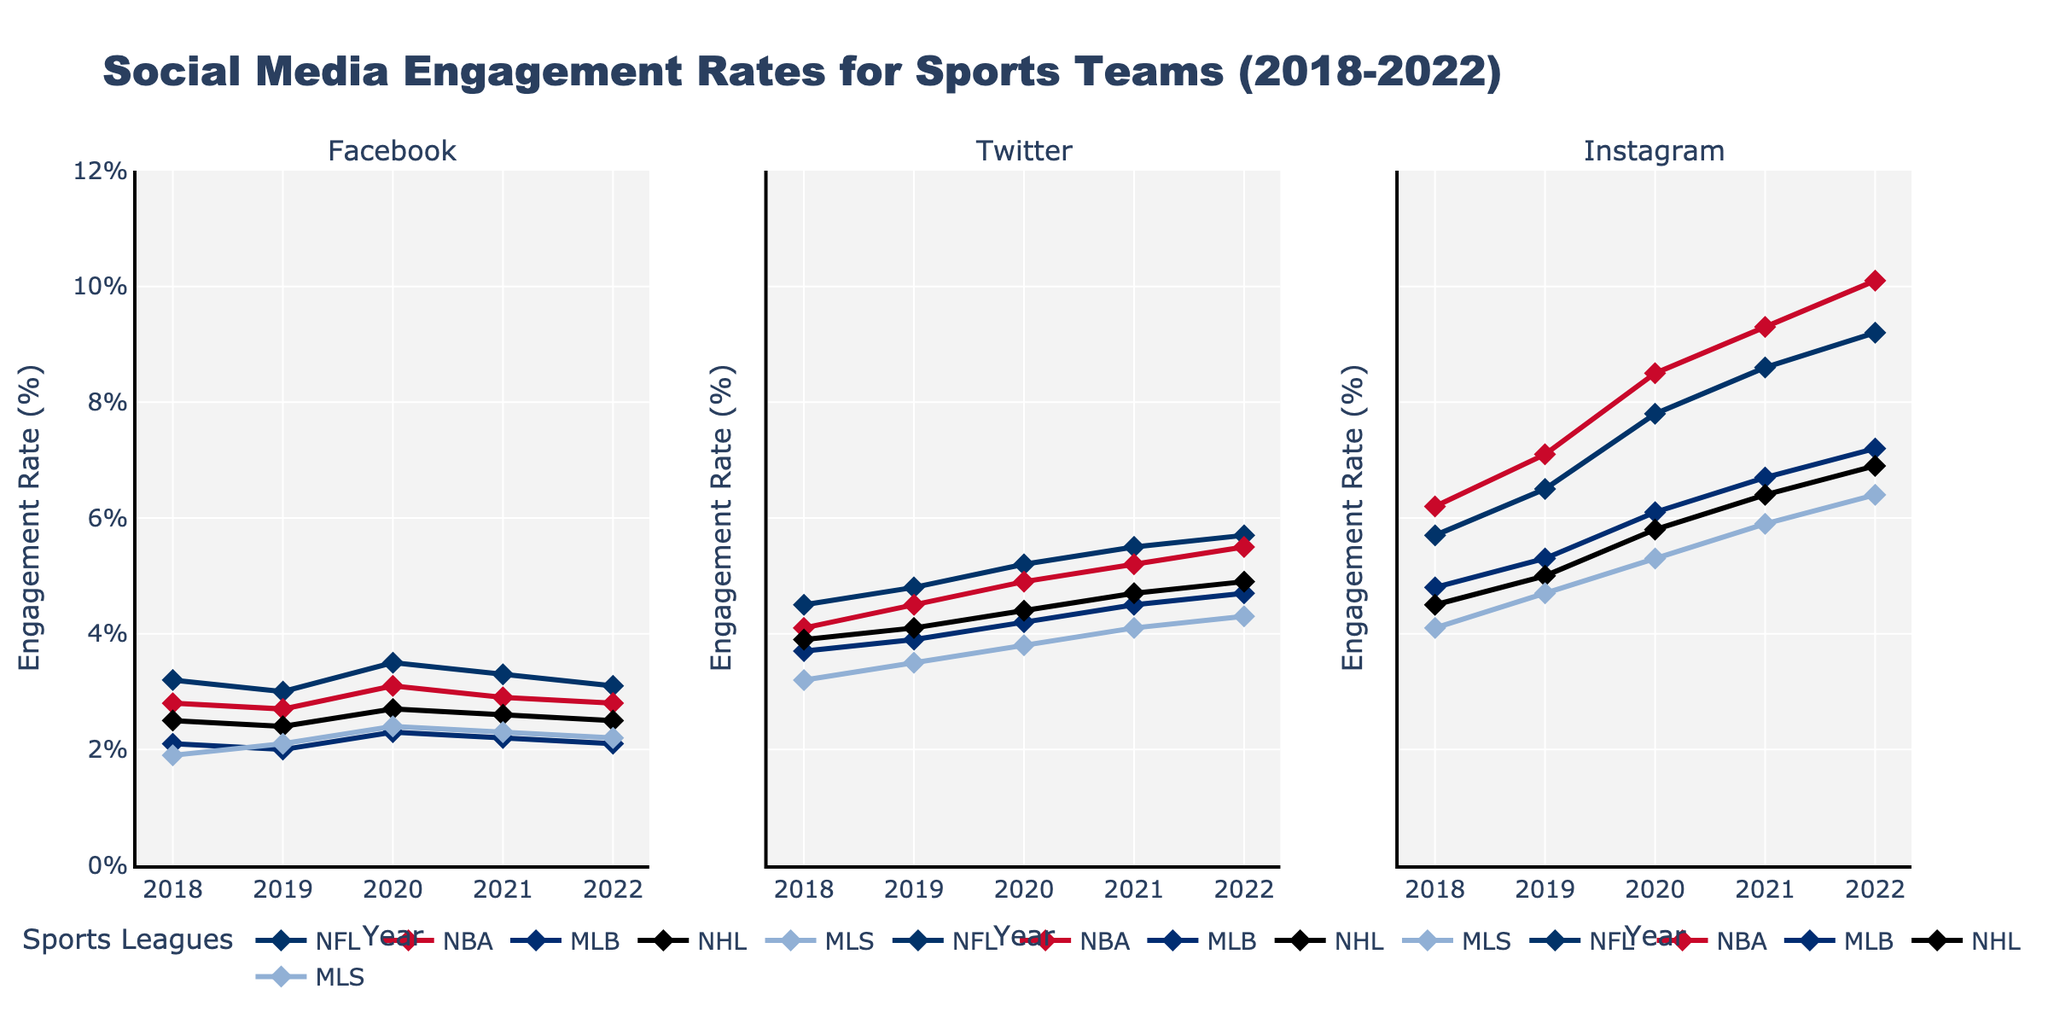Which platform had the highest engagement rate for the NBA in 2022? To find this, look at the Instagram, Facebook, and Twitter plots for 2022 under the NBA marker. The highest engagement rate for the NBA in 2022 is visible on the Instagram plot.
Answer: Instagram Which sport had the lowest engagement rate on Facebook in 2021? To identify the sport with the lowest engagement rate on Facebook in 2021, look at the Facebook plot under the 2021 marker and compare the engagement rates for all the sports. The lowest engagement rate is visible for the NFL.
Answer: NFL How did the engagement rates change for MLS on Instagram from 2018 to 2022? To determine this, observe the plot for Instagram and track the points related to MLS from 2018 to 2022. Calculate the difference between the values. The rates increased from 4.1% in 2018 to 6.4% in 2022.
Answer: Increased by 2.3% Which year did the NFL have the highest engagement rate on Twitter, and what was the value? Check the Twitter sub-plot for the NFL line and compare the values for each year. The highest rate for the NFL on Twitter was in 2022 at 5.7%.
Answer: 2022, 5.7% Does Instagram consistently show the highest engagement rates across all sports compared to Facebook and Twitter from 2018 to 2022? To evaluate consistency, compare the engagement rates across all three platforms each year for a given sport. You'll notice that Instagram consistently shows higher engagement rates than Facebook and Twitter for all sports throughout 2018 to 2022.
Answer: Yes What is the average engagement rate for the NBA on Twitter across all shown years? Calculate the average by summing the engagement rates for the NBA on Twitter across all years (4.1%, 4.5%, 4.9%, 5.2%, 5.5%) and then dividing by the number of years, which is 5. Average = (4.1 + 4.5 + 4.9 + 5.2 + 5.5) / 5 = 4.84%.
Answer: 4.84% Which sport experienced the highest increase in engagement rate on Instagram from 2018 to 2022? Track the Instagram engagement rates for each sport from 2018 to 2022 and calculate the increase. The NFL went from 5.7% in 2018 to 9.2% in 2022, which is an increase of 3.5%, the highest among all sports.
Answer: NFL Did any sport show a decrease in Twitter engagement rates from 2019 to 2020? Compare the Twitter engagement rates for each sport between 2019 and 2020. No sport shows a decrease; instead, all sports show an increase in engagement each year.
Answer: No What was the engagement rate for the NFL on Instagram in 2020? How much did it increase or decrease compared to 2019? Find the NFL's engagement rate on Instagram for 2019 and 2020 from the Instagram plot. The rates are 6.5% in 2019 and 7.8% in 2020. Calculate the change: 7.8% - 6.5% = 1.3% increase.
Answer: 7.8%, increased by 1.3% Which sport had the smallest difference in engagement rates between Facebook and Instagram in 2020? Calculate the engagement rate difference by subtracting the Facebook rate from the Instagram rate for each sport in 2020. Identify the smallest difference. MLS had the smallest difference: 5.3% - 2.4% = 2.9%.
Answer: MLS 